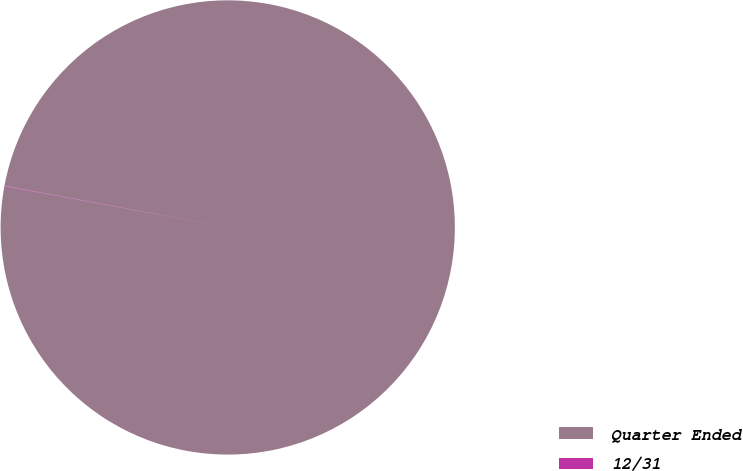Convert chart to OTSL. <chart><loc_0><loc_0><loc_500><loc_500><pie_chart><fcel>Quarter Ended<fcel>12/31<nl><fcel>99.97%<fcel>0.03%<nl></chart> 